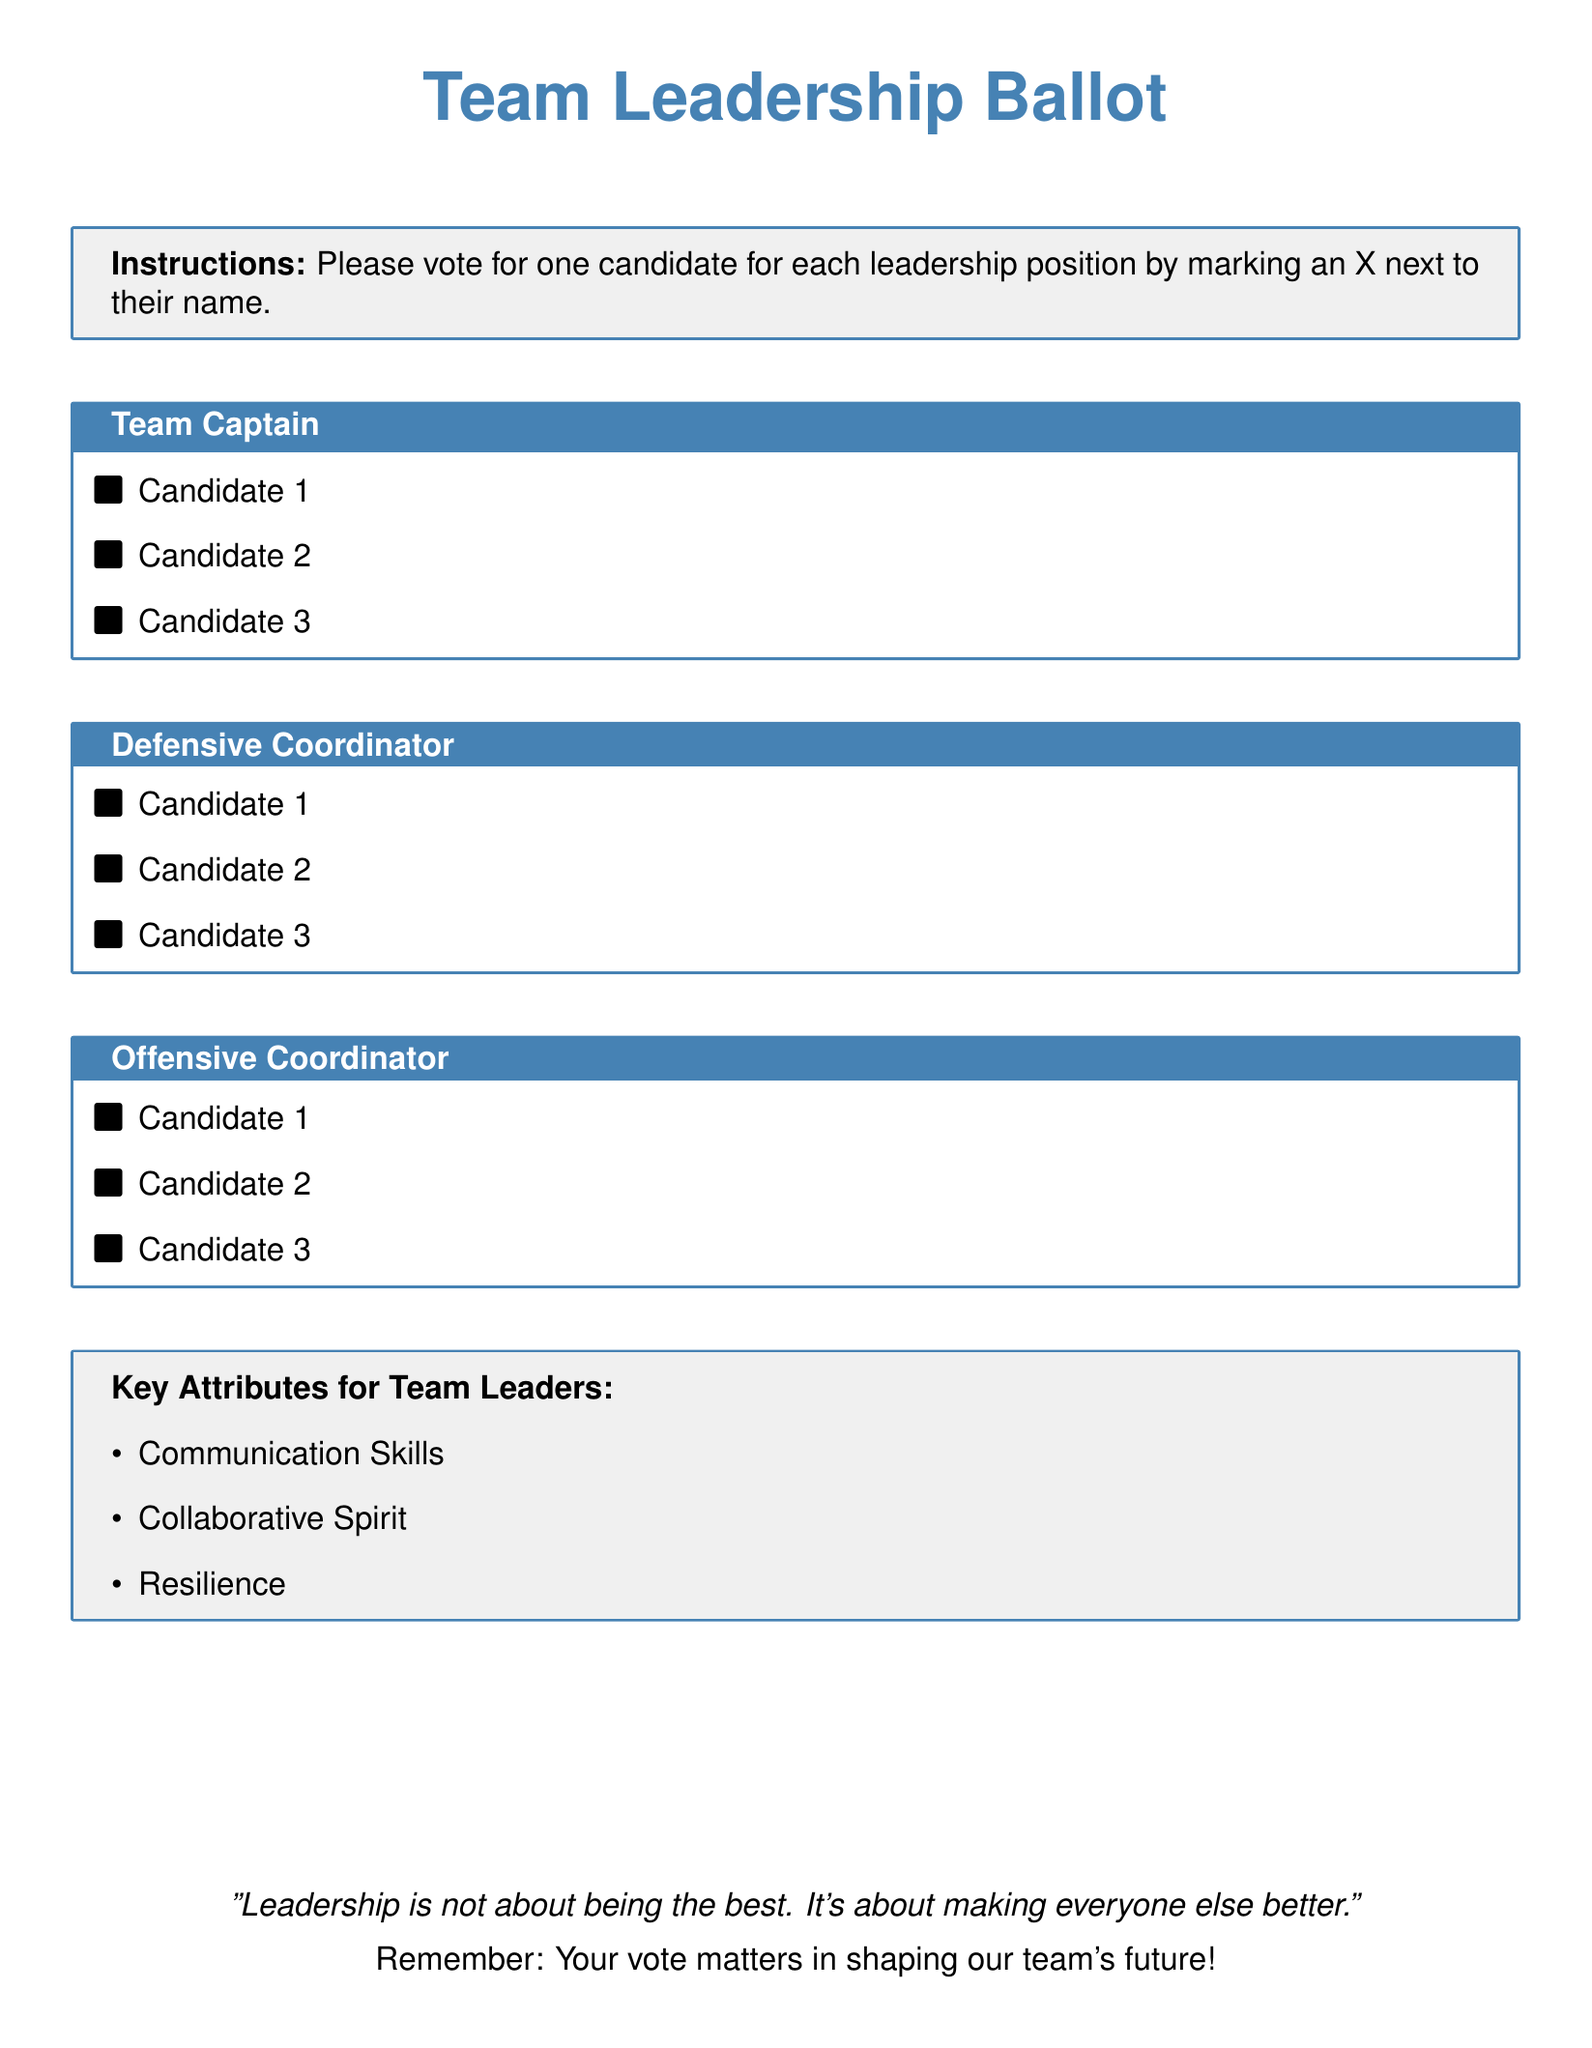What are the titles of the leadership positions being voted on? The document lists the titles for voting, which are Team Captain, Defensive Coordinator, and Offensive Coordinator.
Answer: Team Captain, Defensive Coordinator, Offensive Coordinator How many candidates are there for the Team Captain position? There are three candidates listed under the Team Captain section of the ballot.
Answer: 3 What color is used for the title of the ballot? The color specifically used for the title "Team Leadership Ballot" is designated as ballot blue in the document.
Answer: ballot blue What key attribute focuses on teamwork? The document mentions "Collaborative Spirit" as a key attribute for team leaders, which focuses on teamwork.
Answer: Collaborative Spirit What quote is included at the bottom of the document? The document contains the quote "Leadership is not about being the best. It's about making everyone else better."
Answer: Leadership is not about being the best. It's about making everyone else better What is the primary purpose of the ballot? The primary purpose indicated in the document is to vote for team leadership roles to foster unity and strategy within the team.
Answer: To vote for team leadership roles 